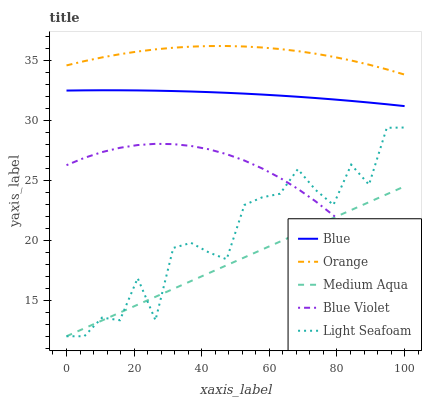Does Medium Aqua have the minimum area under the curve?
Answer yes or no. Yes. Does Orange have the maximum area under the curve?
Answer yes or no. Yes. Does Light Seafoam have the minimum area under the curve?
Answer yes or no. No. Does Light Seafoam have the maximum area under the curve?
Answer yes or no. No. Is Medium Aqua the smoothest?
Answer yes or no. Yes. Is Light Seafoam the roughest?
Answer yes or no. Yes. Is Orange the smoothest?
Answer yes or no. No. Is Orange the roughest?
Answer yes or no. No. Does Light Seafoam have the lowest value?
Answer yes or no. Yes. Does Orange have the lowest value?
Answer yes or no. No. Does Orange have the highest value?
Answer yes or no. Yes. Does Light Seafoam have the highest value?
Answer yes or no. No. Is Blue less than Orange?
Answer yes or no. Yes. Is Blue greater than Light Seafoam?
Answer yes or no. Yes. Does Medium Aqua intersect Light Seafoam?
Answer yes or no. Yes. Is Medium Aqua less than Light Seafoam?
Answer yes or no. No. Is Medium Aqua greater than Light Seafoam?
Answer yes or no. No. Does Blue intersect Orange?
Answer yes or no. No. 